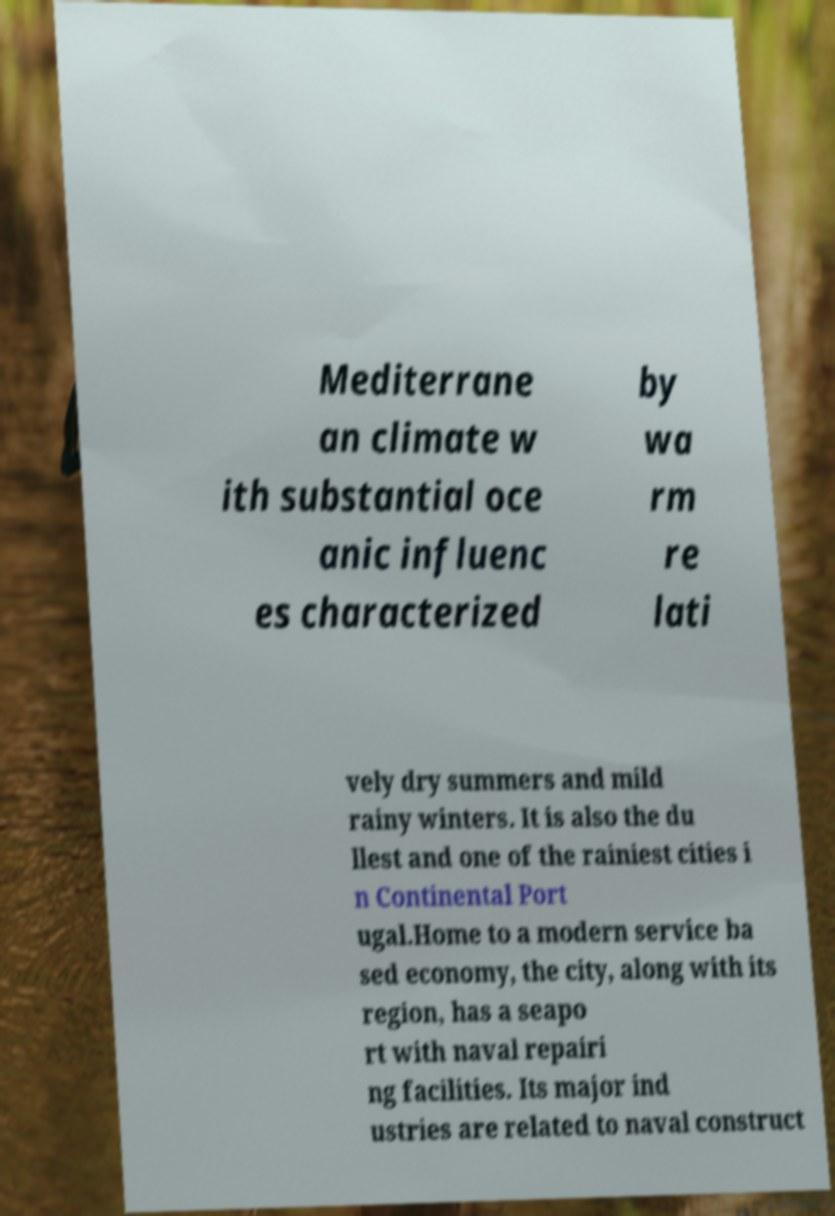Can you accurately transcribe the text from the provided image for me? Mediterrane an climate w ith substantial oce anic influenc es characterized by wa rm re lati vely dry summers and mild rainy winters. It is also the du llest and one of the rainiest cities i n Continental Port ugal.Home to a modern service ba sed economy, the city, along with its region, has a seapo rt with naval repairi ng facilities. Its major ind ustries are related to naval construct 